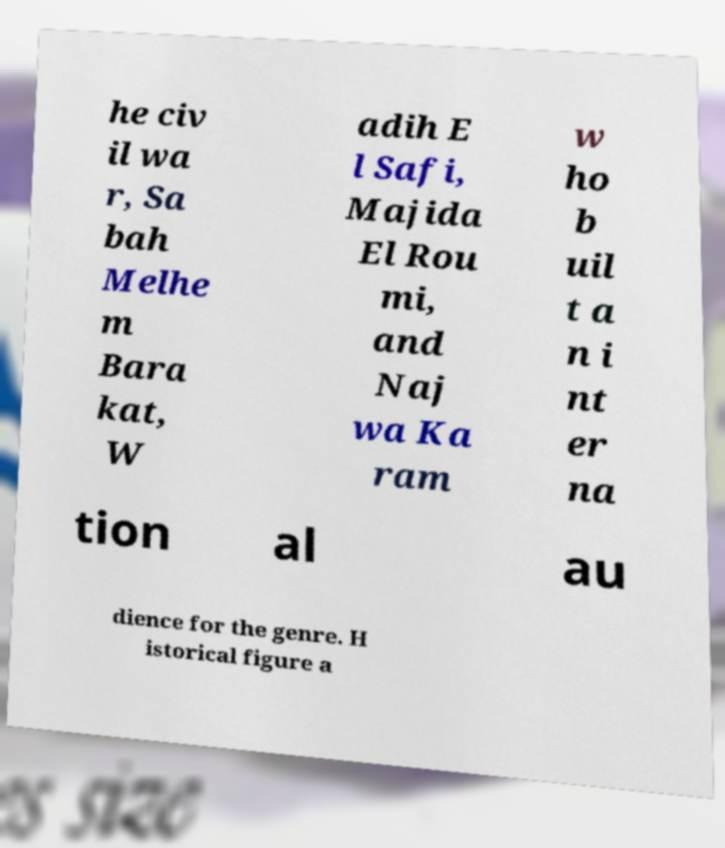Could you assist in decoding the text presented in this image and type it out clearly? he civ il wa r, Sa bah Melhe m Bara kat, W adih E l Safi, Majida El Rou mi, and Naj wa Ka ram w ho b uil t a n i nt er na tion al au dience for the genre. H istorical figure a 